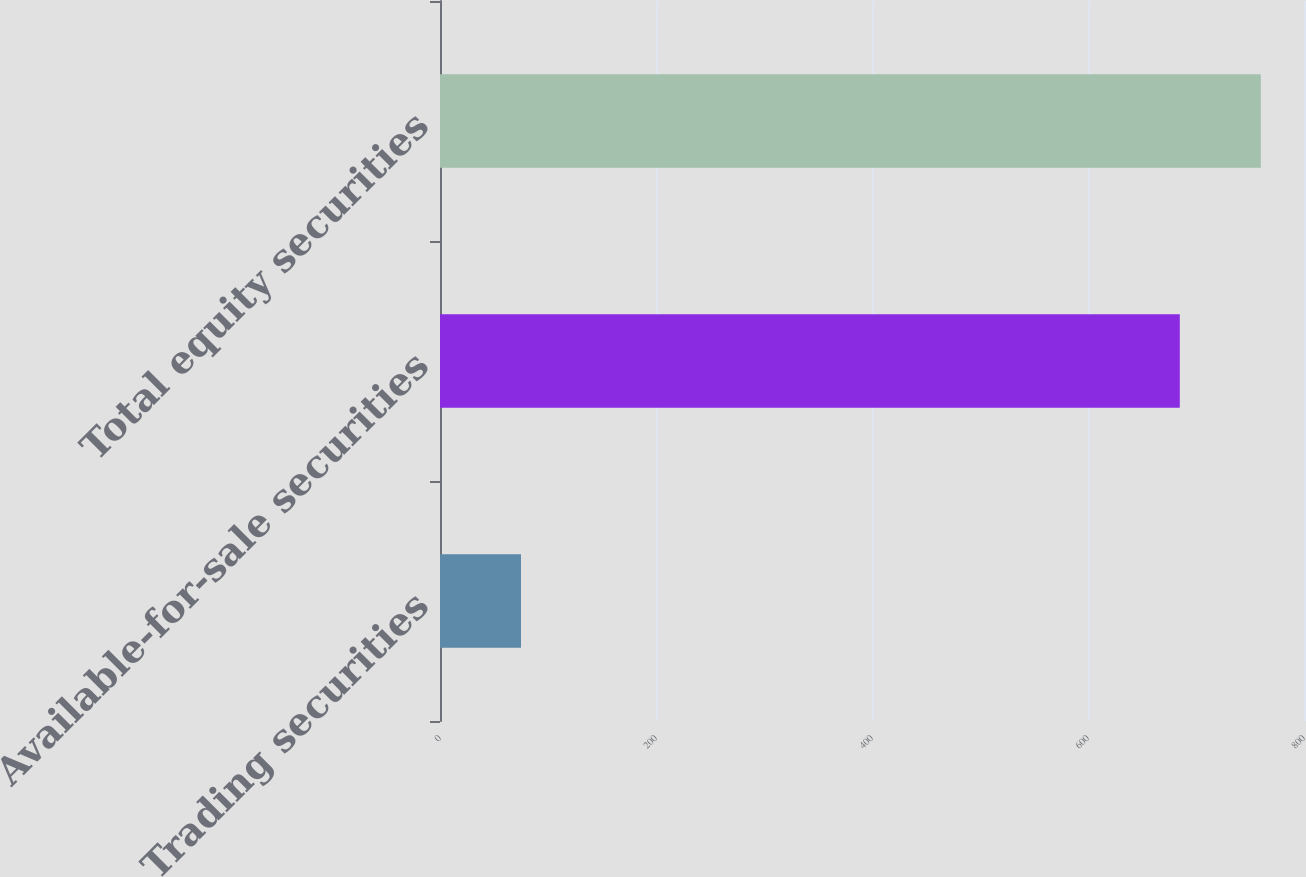Convert chart to OTSL. <chart><loc_0><loc_0><loc_500><loc_500><bar_chart><fcel>Trading securities<fcel>Available-for-sale securities<fcel>Total equity securities<nl><fcel>75<fcel>685<fcel>760<nl></chart> 